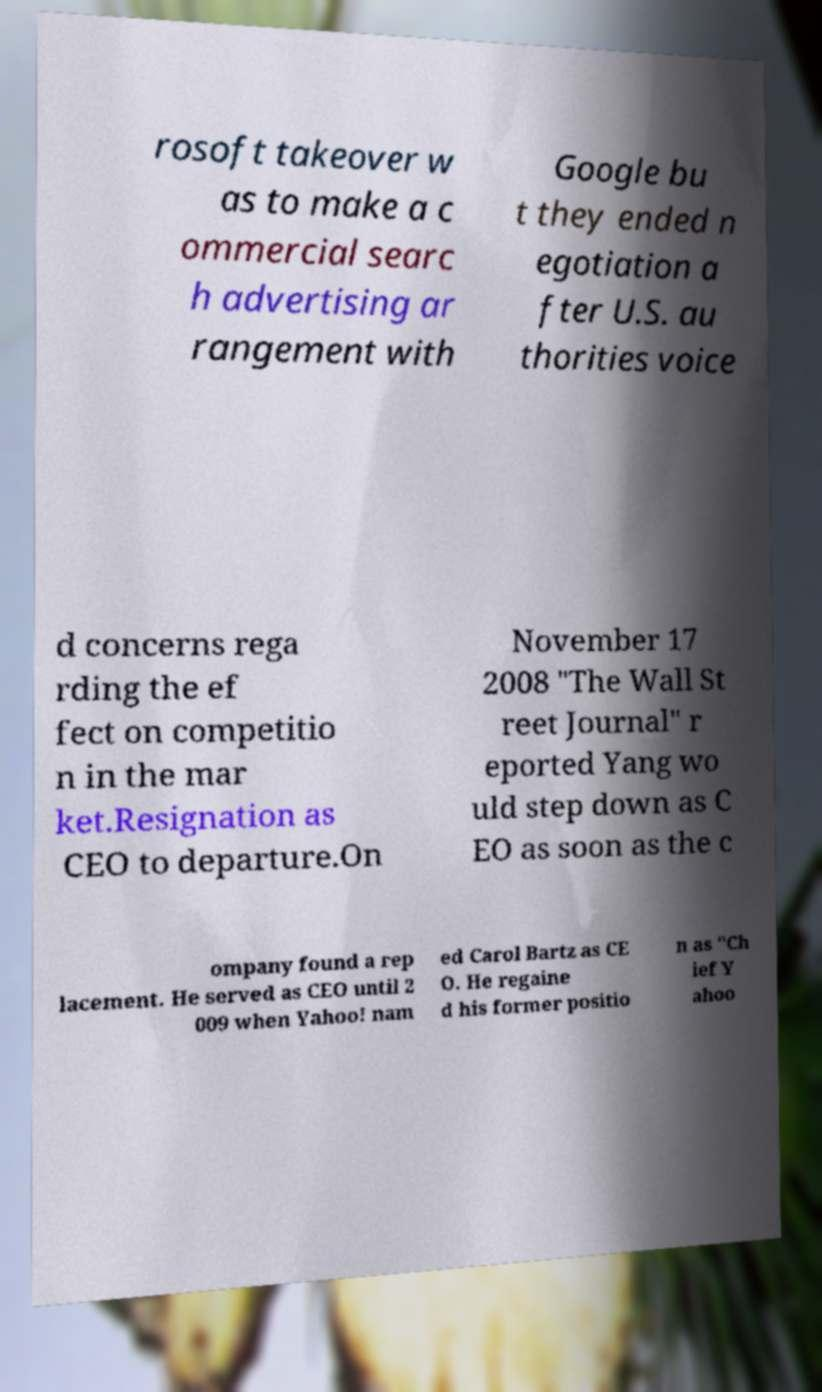Could you assist in decoding the text presented in this image and type it out clearly? rosoft takeover w as to make a c ommercial searc h advertising ar rangement with Google bu t they ended n egotiation a fter U.S. au thorities voice d concerns rega rding the ef fect on competitio n in the mar ket.Resignation as CEO to departure.On November 17 2008 "The Wall St reet Journal" r eported Yang wo uld step down as C EO as soon as the c ompany found a rep lacement. He served as CEO until 2 009 when Yahoo! nam ed Carol Bartz as CE O. He regaine d his former positio n as "Ch ief Y ahoo 